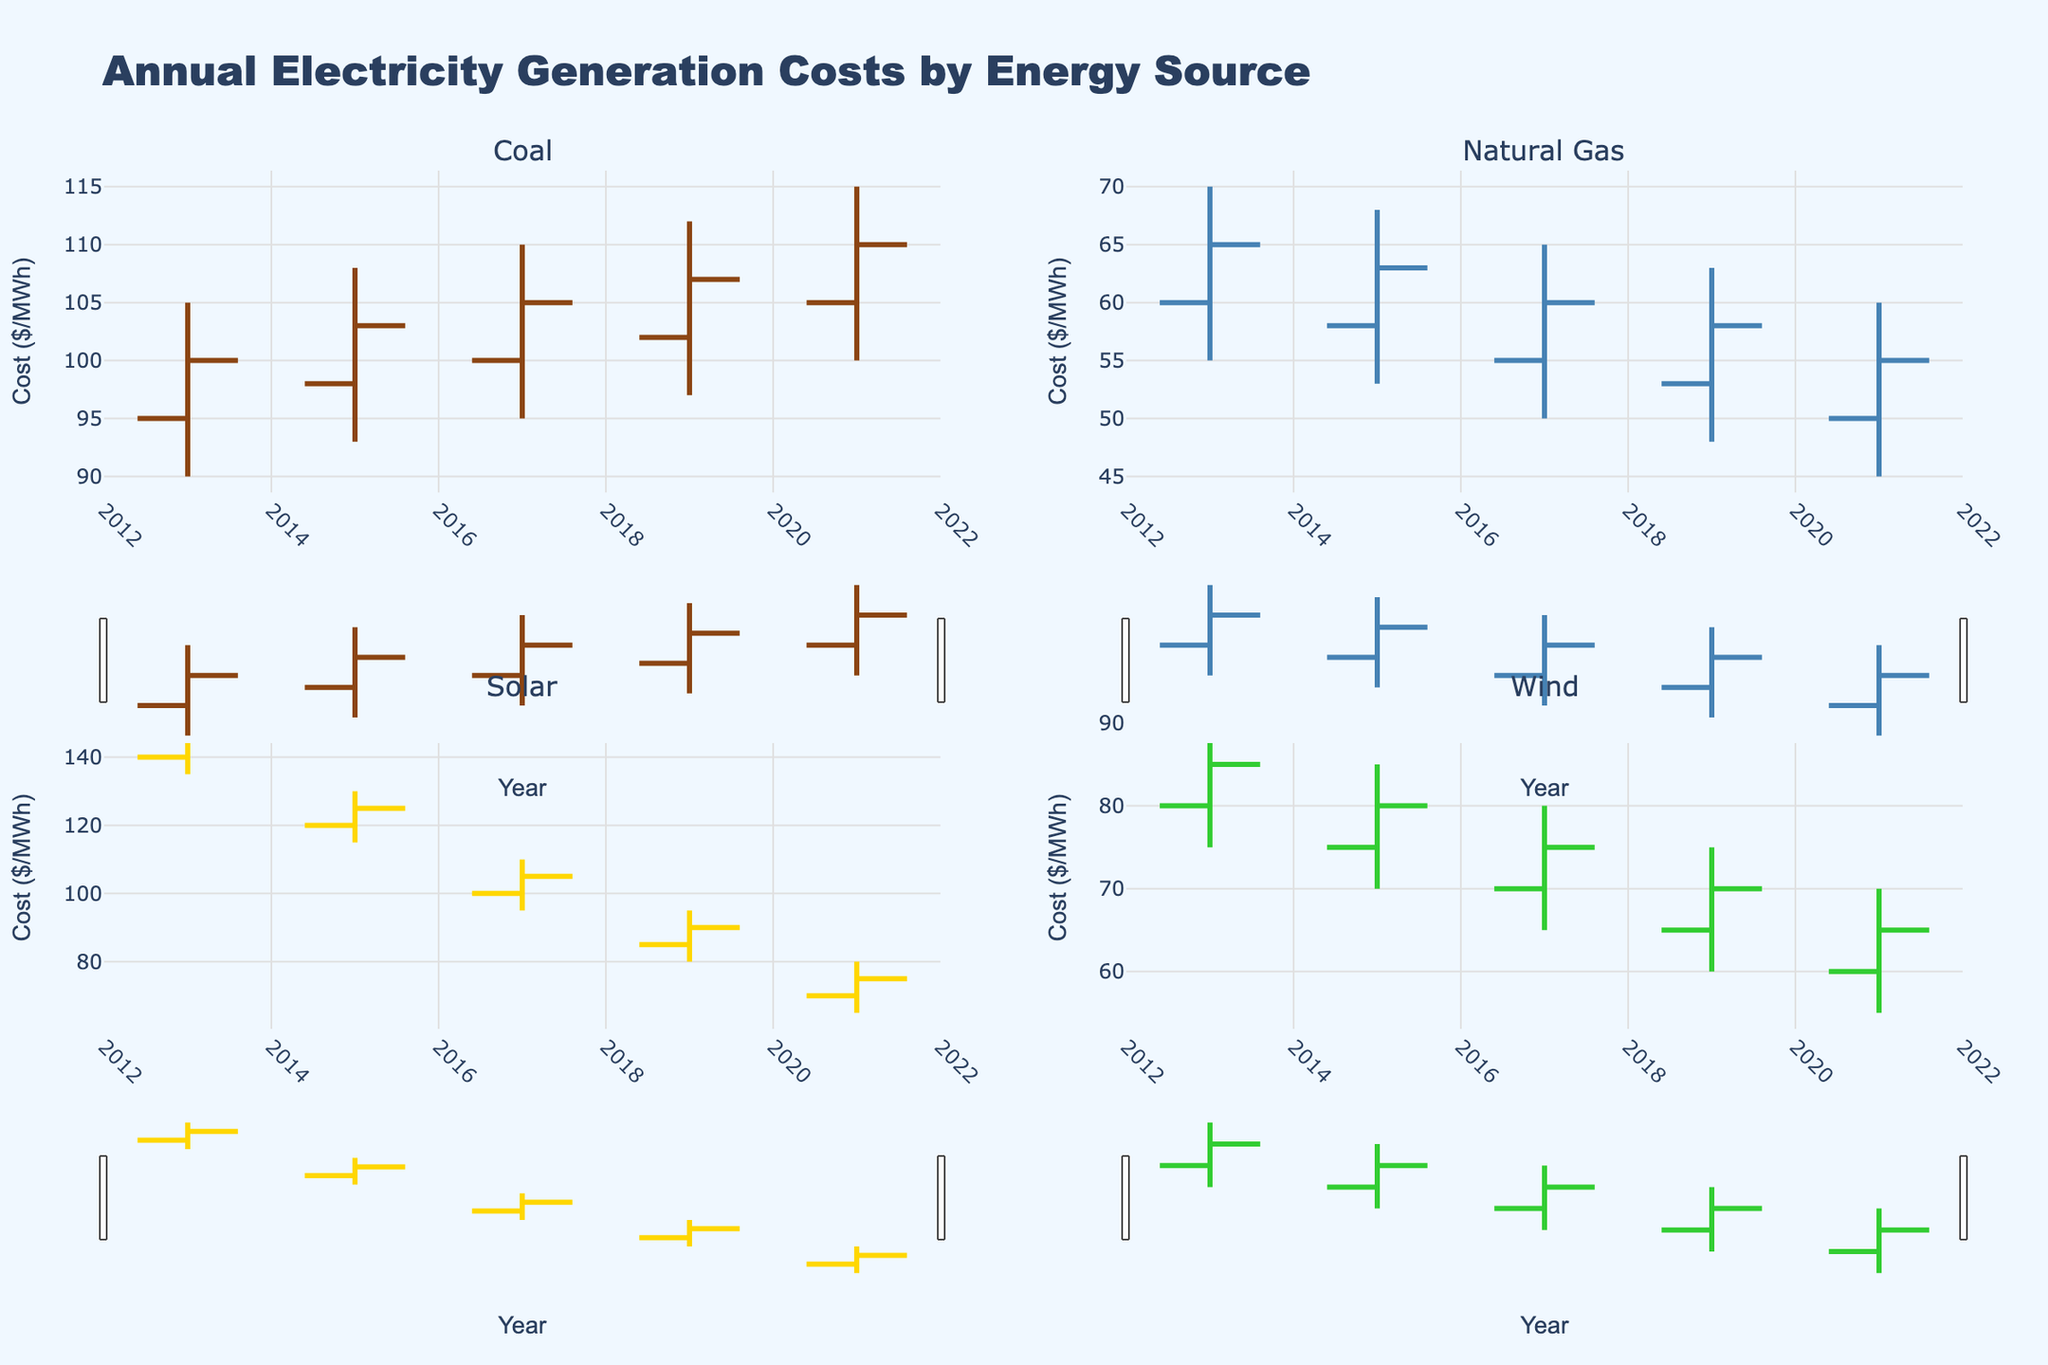what is the title of the figure? The title is usually located at the top of the chart. On looking at the figure, the title reads "Annual Electricity Generation Costs by Energy Source".
Answer: Annual Electricity Generation Costs by Energy Source How many energy sources are compared in the figure? The chart has subplots for different energy sources. It includes Coal, Natural Gas, Solar, and Wind. Counting these subplots gives a total of 4 energy sources.
Answer: 4 Which year had the highest closing cost for Solar energy? By inspecting the OHLC data for Solar energy on each subplot, the closing prices can be seen. In 2013: 145, 2015: 125, 2017: 105, 2019: 90, 2021: 75. The highest closing price is in 2013.
Answer: 2013 What is the trend in closing costs for Natural Gas from 2013 to 2021? Reviewing the closing prices in each year for Natural Gas: 2013: 65, 2015: 63, 2017: 60, 2019: 58, 2021: 55, it can be seen that the closing prices decrease over time.
Answer: Decreasing Which energy source experienced the lowest low in 2021? For 2021, examine the 'Low' column values for each energy source. Coal: 100, Natural Gas: 45, Solar: 65, Wind: 55. The lowest value is for Natural Gas at 45.
Answer: Natural Gas What is the average closing cost of Coal from 2013 to 2021? Coal closing costs over the years: 2013: 100, 2015: 103, 2017: 105, 2019: 107, 2021: 110. Average = (100+103+105+107+110) / 5 = 525 / 5 = 105.
Answer: 105 Which energy source had the most stable cost range in 2013? Stability in OHLC charts can be seen by the range between High and Low prices. For 2013: Coal range is 15, Natural Gas range is 15, Solar range is 15, Wind range is 15. All have the same range.
Answer: All have equal range What was the difference between the highest and lowest closing costs for Wind energy from 2013 to 2021? Wind closing prices: 2013: 85, 2015: 80, 2017: 75, 2019: 70, 2021: 65. Highest closing is 85 and lowest is 65. Difference = 85 - 65 = 20.
Answer: 20 Which energy source had the smallest decrease in closing cost from 2013 to 2021? Examine closing costs between 2013 and 2021 for each source and calculate the decrease: 
Coal: 100 to 110 (increase),
Natural Gas: 65 to 55 (decrease by 10),
Solar: 145 to 75 (decrease by 70),
Wind: 85 to 65 (decrease by 20). 
Smallest decrease is Natural Gas, 10 units.
Answer: Natural Gas 